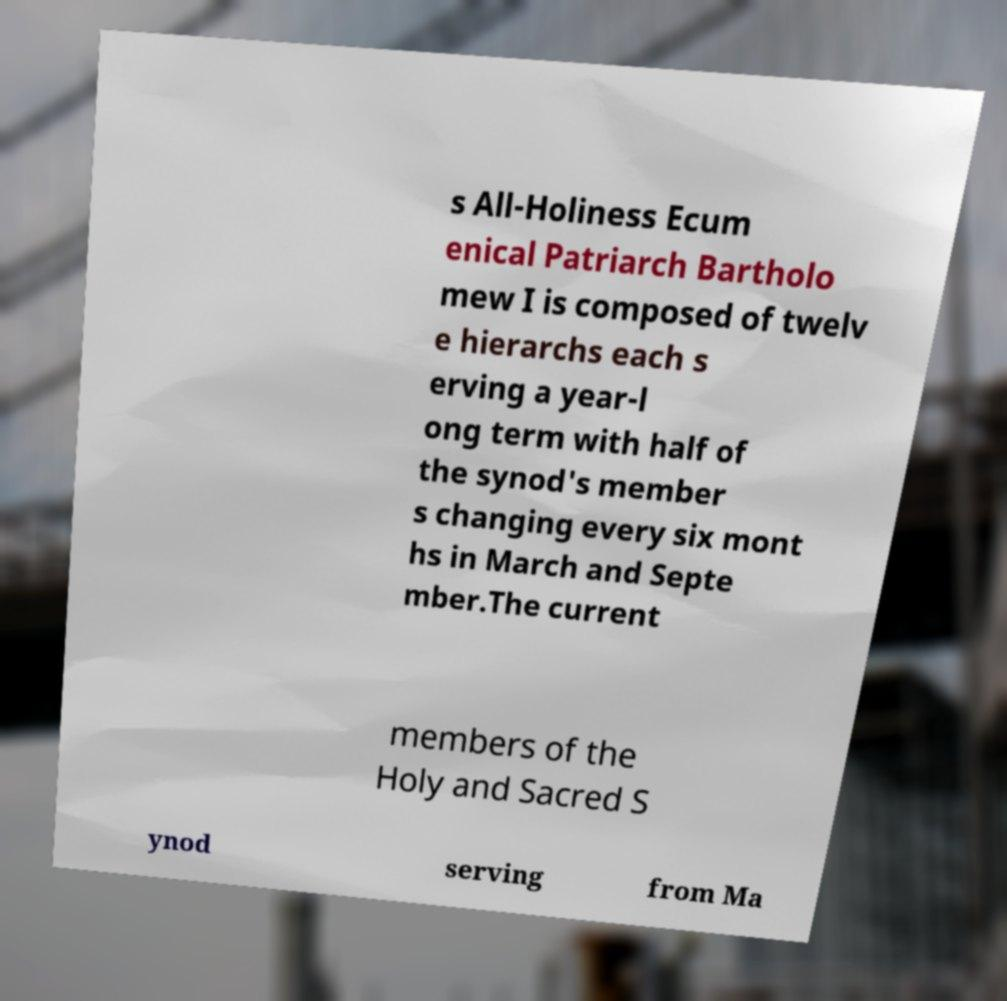I need the written content from this picture converted into text. Can you do that? s All-Holiness Ecum enical Patriarch Bartholo mew I is composed of twelv e hierarchs each s erving a year-l ong term with half of the synod's member s changing every six mont hs in March and Septe mber.The current members of the Holy and Sacred S ynod serving from Ma 